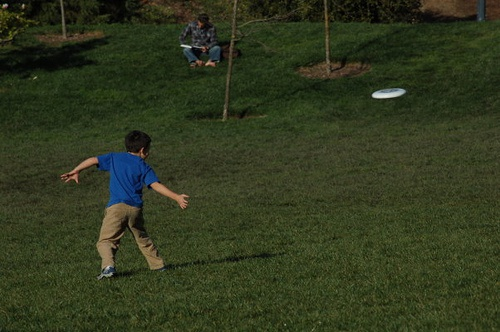Describe the objects in this image and their specific colors. I can see people in black, navy, and gray tones, people in black, gray, darkblue, and purple tones, and frisbee in black, darkgray, gray, and lightgray tones in this image. 